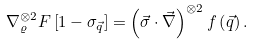Convert formula to latex. <formula><loc_0><loc_0><loc_500><loc_500>\nabla _ { \varrho } ^ { \otimes 2 } F \left [ 1 - \sigma _ { \vec { q } } \right ] = \left ( \vec { \sigma } \cdot \vec { \nabla } \right ) ^ { \otimes 2 } f \left ( \vec { q } \right ) .</formula> 